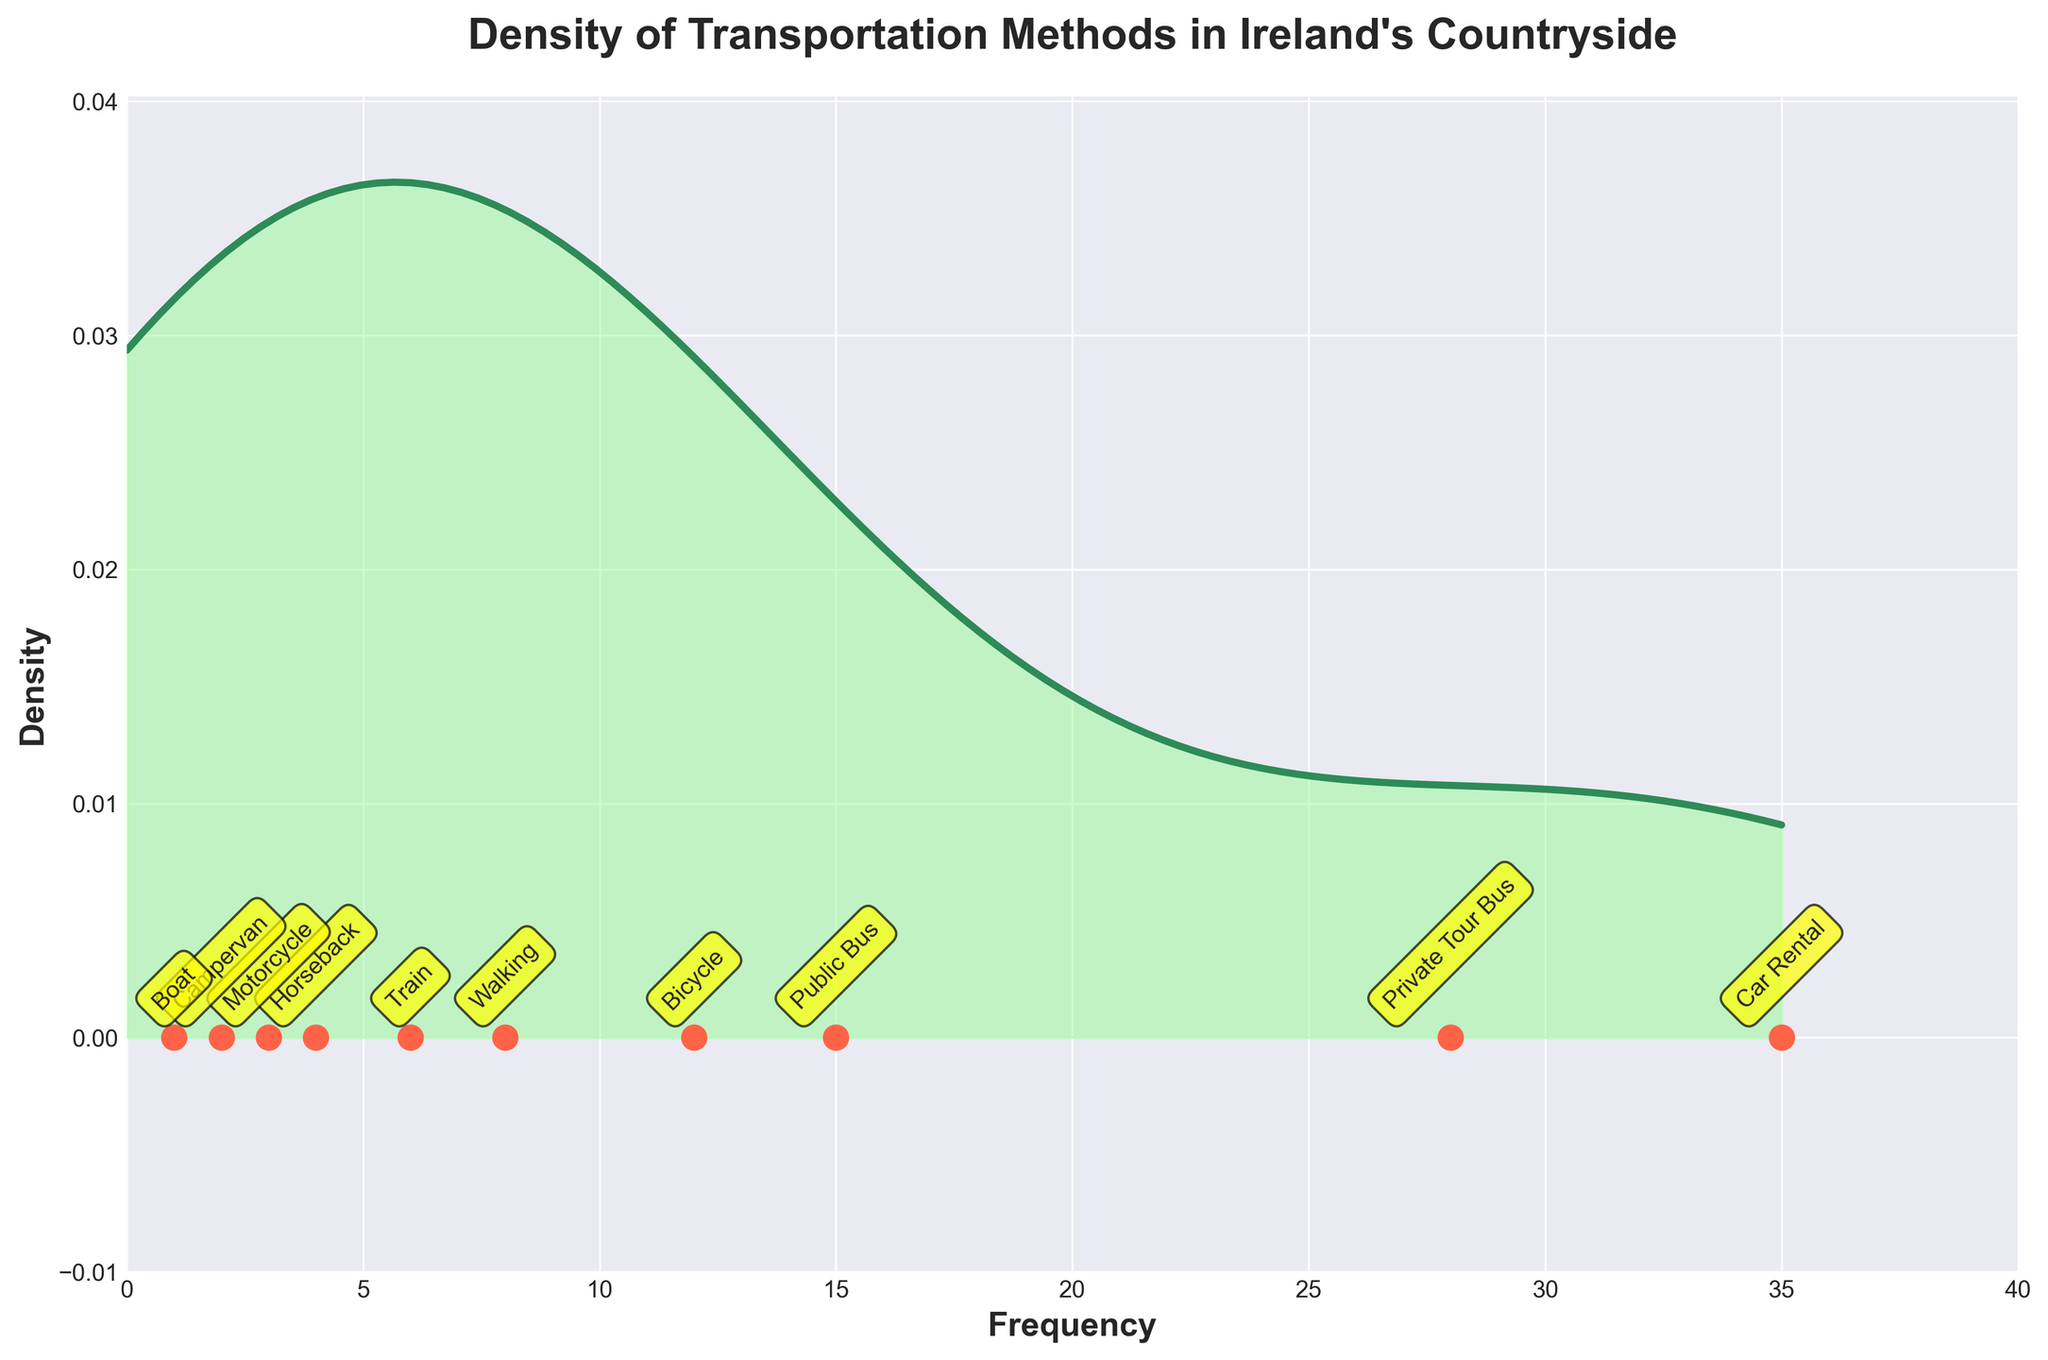What is the title of the plot? The title of the plot is displayed at the top and reads "Density of Transportation Methods in Ireland's Countryside"
Answer: Density of Transportation Methods in Ireland's Countryside What does the x-axis represent? The x-axis label is "Frequency," indicating it represents the frequency of each transportation method.
Answer: Frequency What does the y-axis represent? The y-axis label is "Density," indicating it represents the density estimation of the frequencies.
Answer: Density Which transportation method has the highest frequency? Looking at the scatter points and their labels, "Car Rental" has the highest frequency, marked at 35.
Answer: Car Rental How many transportation methods are shown in total? By counting the scatter points and their labels, we can see that there are 10 transportation methods shown.
Answer: 10 Which transportation method has the lowest frequency? By identifying the scatter point labeled "Boat," we can see it has the lowest frequency at 1.
Answer: Boat How does the frequency of "Private Tour Bus" compare to "Public Bus"? By examining the scatter points, "Private Tour Bus" has a frequency of 28 while "Public Bus" has a frequency of 15. Hence, "Private Tour Bus" has a higher frequency than "Public Bus."
Answer: Private Tour Bus is higher What is the range of frequencies shown in the plot? The lowest frequency is 1 (Boat) and the highest frequency is 35 (Car Rental), indicating the range is from 1 to 35.
Answer: 1 to 35 Which transportation methods have a frequency of less than 10? By looking at the scatter points and their labels, "Walking" (8), "Train" (6), "Horseback" (4), "Motorcycle" (3), "Campervan" (2), and "Boat" (1) all have frequencies less than 10.
Answer: Walking, Train, Horseback, Motorcycle, Campervan, Boat What is the color used for the KDE line in the density plot? The KDE line is colored green, closer to a shade of forest green.
Answer: Green 